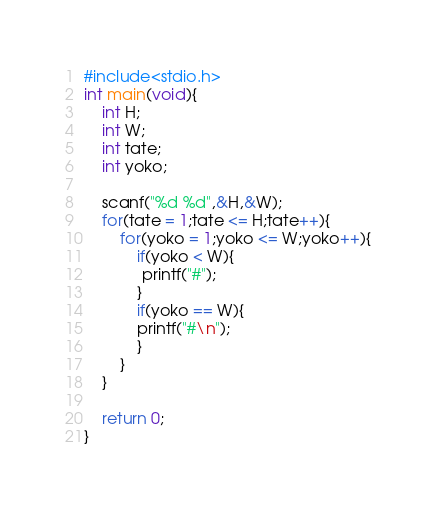Convert code to text. <code><loc_0><loc_0><loc_500><loc_500><_C_>#include<stdio.h>
int main(void){
	int H;
	int W;
	int tate;
	int yoko;
	
	scanf("%d %d",&H,&W);
	for(tate = 1;tate <= H;tate++){
		for(yoko = 1;yoko <= W;yoko++){
			if(yoko < W){
			 printf("#");
			}
			if(yoko == W){
			printf("#\n");
			}
		}
	}
	
	return 0;
}</code> 